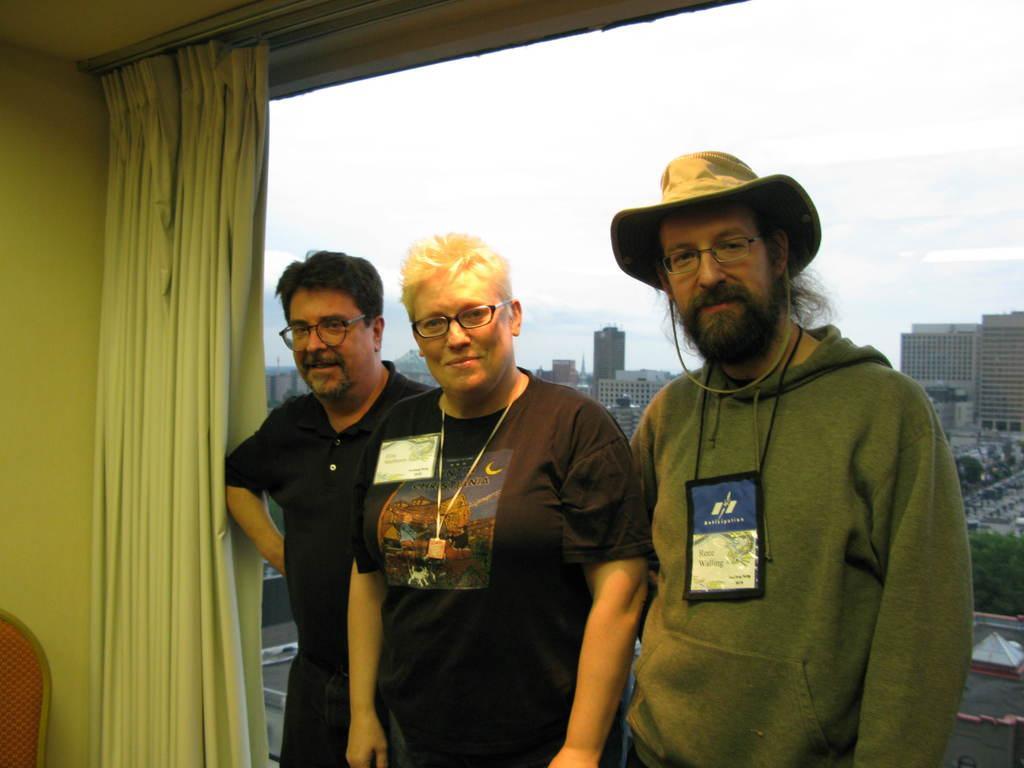Describe this image in one or two sentences. This is an inside view. Here I can see three persons standing and smiling by looking at the picture. At the back of these people there is a glass through which we can see the outside view. In the outside there are many trees and buildings and also I can see the sky. On the left side there is a curtain and a wall. In the bottom left-hand corner there is a chair. 